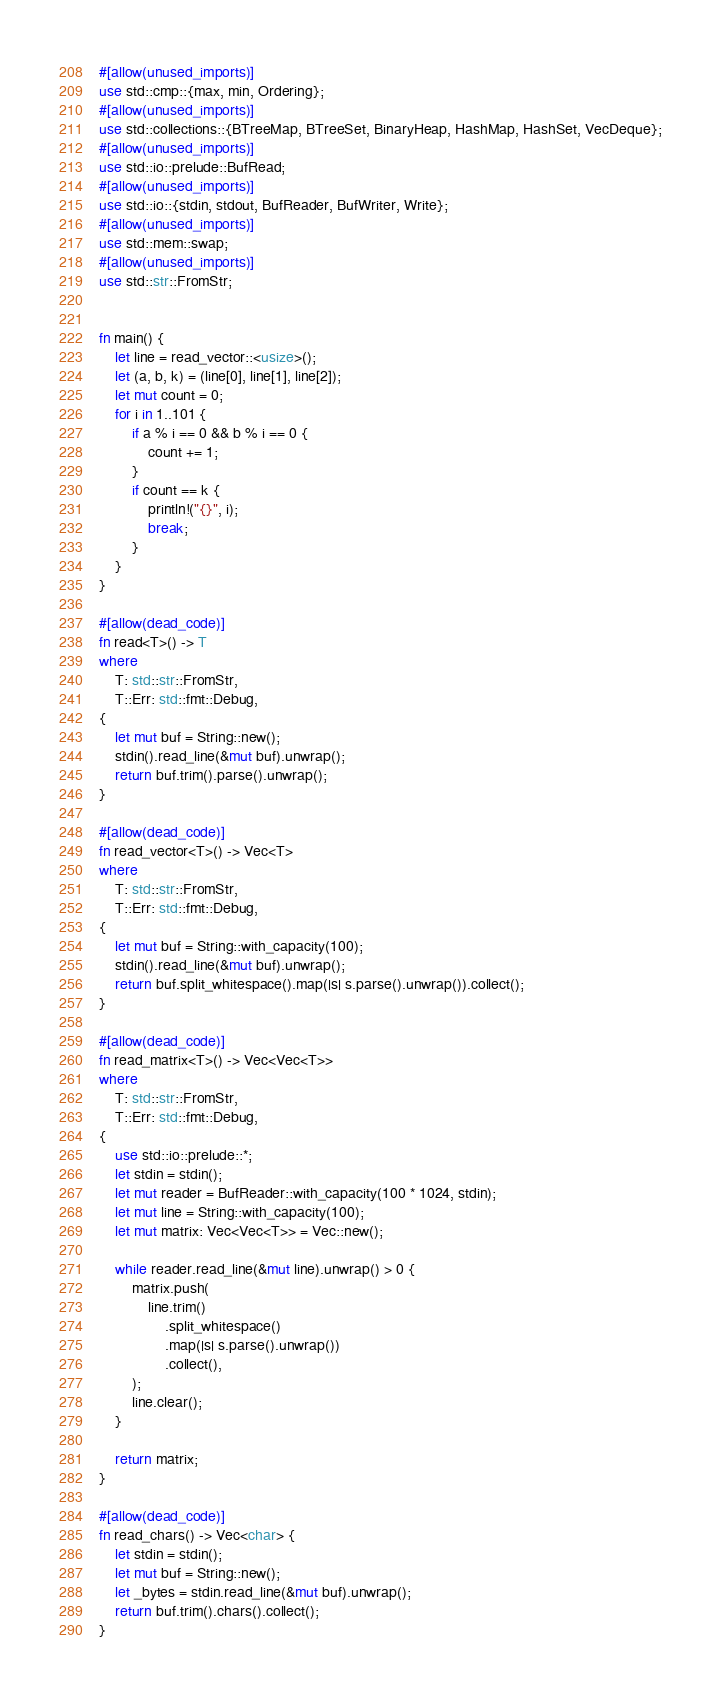Convert code to text. <code><loc_0><loc_0><loc_500><loc_500><_Rust_>#[allow(unused_imports)]
use std::cmp::{max, min, Ordering};
#[allow(unused_imports)]
use std::collections::{BTreeMap, BTreeSet, BinaryHeap, HashMap, HashSet, VecDeque};
#[allow(unused_imports)]
use std::io::prelude::BufRead;
#[allow(unused_imports)]
use std::io::{stdin, stdout, BufReader, BufWriter, Write};
#[allow(unused_imports)]
use std::mem::swap;
#[allow(unused_imports)]
use std::str::FromStr;


fn main() {
    let line = read_vector::<usize>();
    let (a, b, k) = (line[0], line[1], line[2]);
    let mut count = 0;
    for i in 1..101 {
        if a % i == 0 && b % i == 0 {
            count += 1;
        }
        if count == k {
            println!("{}", i);
            break;
        }
    }
}

#[allow(dead_code)]
fn read<T>() -> T
where
    T: std::str::FromStr,
    T::Err: std::fmt::Debug,
{
    let mut buf = String::new();
    stdin().read_line(&mut buf).unwrap();
    return buf.trim().parse().unwrap();
}

#[allow(dead_code)]
fn read_vector<T>() -> Vec<T>
where
    T: std::str::FromStr,
    T::Err: std::fmt::Debug,
{
    let mut buf = String::with_capacity(100);
    stdin().read_line(&mut buf).unwrap();
    return buf.split_whitespace().map(|s| s.parse().unwrap()).collect();
}

#[allow(dead_code)]
fn read_matrix<T>() -> Vec<Vec<T>>
where
    T: std::str::FromStr,
    T::Err: std::fmt::Debug,
{
    use std::io::prelude::*;
    let stdin = stdin();
    let mut reader = BufReader::with_capacity(100 * 1024, stdin);
    let mut line = String::with_capacity(100);
    let mut matrix: Vec<Vec<T>> = Vec::new();

    while reader.read_line(&mut line).unwrap() > 0 {
        matrix.push(
            line.trim()
                .split_whitespace()
                .map(|s| s.parse().unwrap())
                .collect(),
        );
        line.clear();
    }

    return matrix;
}

#[allow(dead_code)]
fn read_chars() -> Vec<char> {
    let stdin = stdin();
    let mut buf = String::new();
    let _bytes = stdin.read_line(&mut buf).unwrap();
    return buf.trim().chars().collect();
}
</code> 